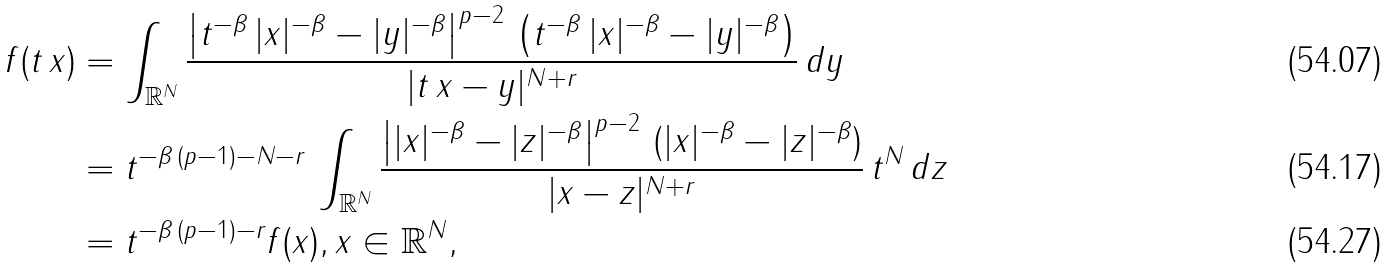<formula> <loc_0><loc_0><loc_500><loc_500>f ( t \, x ) & = \int _ { \mathbb { R } ^ { N } } \frac { \left | t ^ { - \beta } \, | x | ^ { - \beta } - | y | ^ { - \beta } \right | ^ { p - 2 } \, \left ( t ^ { - \beta } \, | x | ^ { - \beta } - | y | ^ { - \beta } \right ) } { | t \, x - y | ^ { N + r } } \, d y \\ & = t ^ { - \beta \, ( p - 1 ) - N - r } \, \int _ { \mathbb { R } ^ { N } } \frac { \left | | x | ^ { - \beta } - | z | ^ { - \beta } \right | ^ { p - 2 } \, ( | x | ^ { - \beta } - | z | ^ { - \beta } ) } { | x - z | ^ { N + r } } \, t ^ { N } \, d z \\ & = t ^ { - \beta \, ( p - 1 ) - r } f ( x ) , x \in \mathbb { R } ^ { N } ,</formula> 